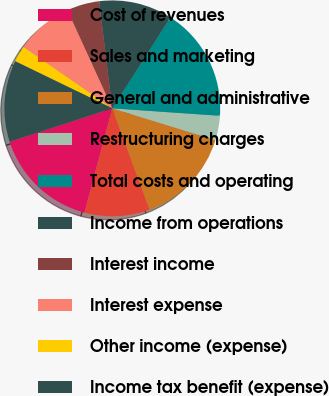Convert chart to OTSL. <chart><loc_0><loc_0><loc_500><loc_500><pie_chart><fcel>Cost of revenues<fcel>Sales and marketing<fcel>General and administrative<fcel>Restructuring charges<fcel>Total costs and operating<fcel>Income from operations<fcel>Interest income<fcel>Interest expense<fcel>Other income (expense)<fcel>Income tax benefit (expense)<nl><fcel>15.85%<fcel>9.76%<fcel>14.63%<fcel>3.66%<fcel>17.07%<fcel>10.98%<fcel>4.88%<fcel>8.54%<fcel>2.44%<fcel>12.2%<nl></chart> 